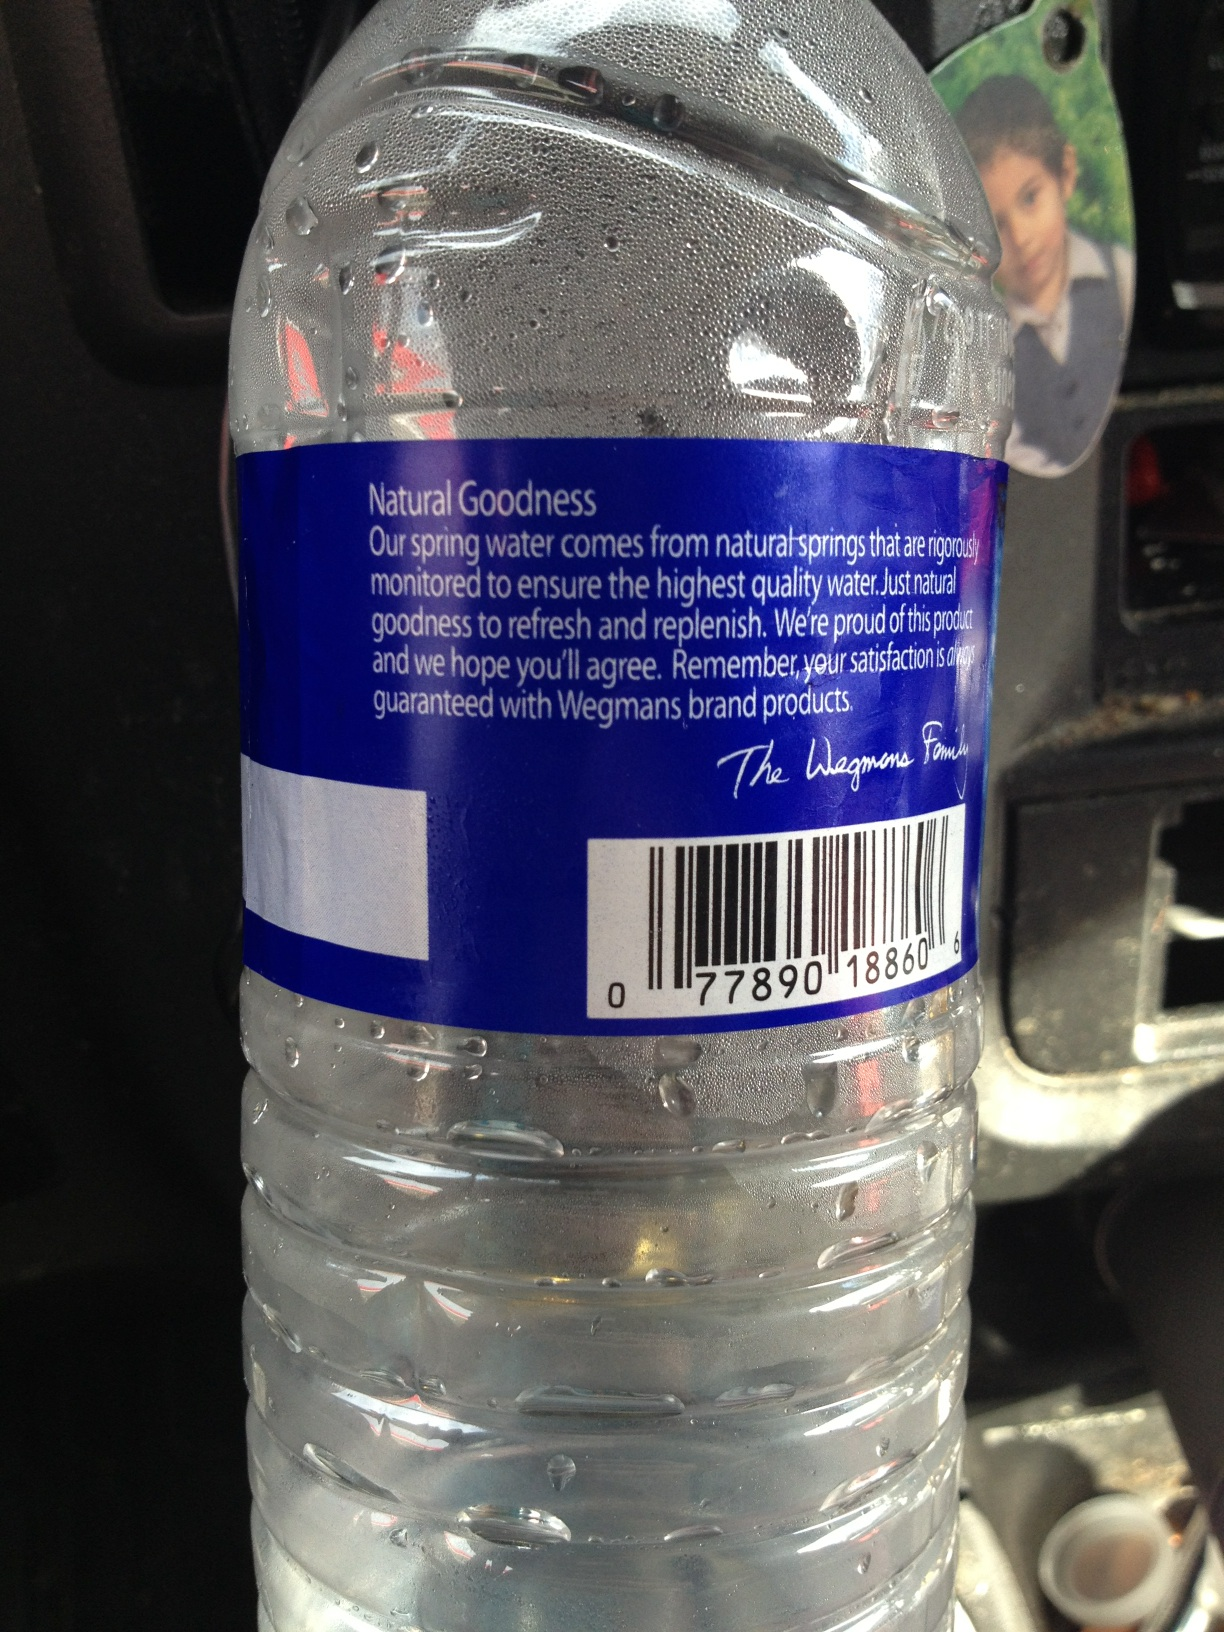Describe a realistic scenario where someone might use this water bottle on a daily basis. A typical scenario might involve someone grabbing this water bottle on their way to the gym. They'd keep it in their gym bag and sip from it between sets to stay hydrated. It’s also common to see this bottle on an office desk, with someone drinking from it throughout the day to maintain their hydration levels. 